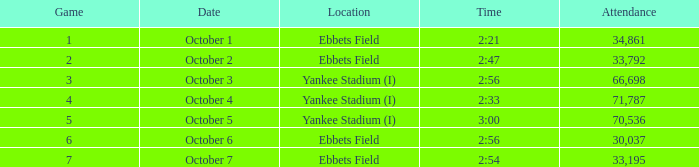What is the average game on october 1st? 1.0. Can you parse all the data within this table? {'header': ['Game', 'Date', 'Location', 'Time', 'Attendance'], 'rows': [['1', 'October 1', 'Ebbets Field', '2:21', '34,861'], ['2', 'October 2', 'Ebbets Field', '2:47', '33,792'], ['3', 'October 3', 'Yankee Stadium (I)', '2:56', '66,698'], ['4', 'October 4', 'Yankee Stadium (I)', '2:33', '71,787'], ['5', 'October 5', 'Yankee Stadium (I)', '3:00', '70,536'], ['6', 'October 6', 'Ebbets Field', '2:56', '30,037'], ['7', 'October 7', 'Ebbets Field', '2:54', '33,195']]} 